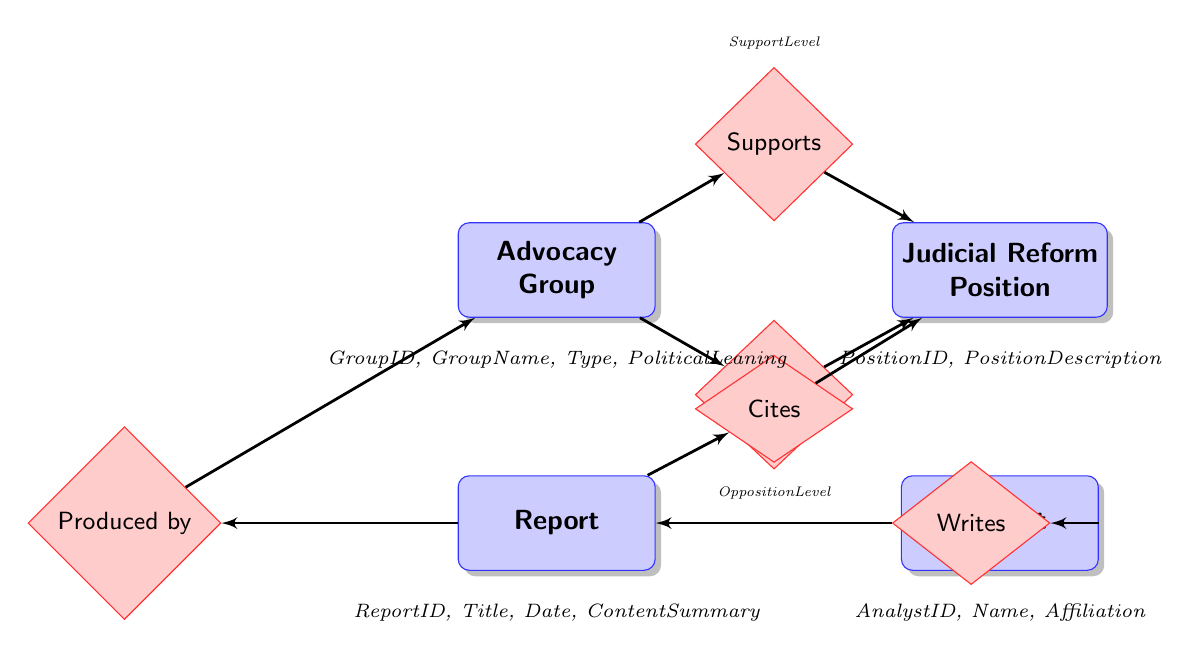What are the entities represented in the diagram? The entities in the diagram are Advocacy Group, Judicial Reform Position, Report, and Analyst. These are depicted as rectangles labeled with their names in the diagram.
Answer: Advocacy Group, Judicial Reform Position, Report, Analyst How many relationships are depicted between Advocacy Group and Judicial Reform Position? There are two relationships depicted between Advocacy Group and Judicial Reform Position: Supports and Opposes. Each of these relationships connects the two entities, indicating differing stances on judicial reform positions.
Answer: Two What attribute is associated with the Supports relationship? The attribute associated with the Supports relationship is SupportLevel. This attribute indicates how strongly an Advocacy Group supports a particular Judicial Reform Position.
Answer: SupportLevel Which entity produces the Report? The entity that produces the Report is Advocacy Group, as indicated by the relationship labeled "Produced by" connecting the Report entity to the Advocacy Group entity.
Answer: Advocacy Group Which entity writes the Report? The entity that writes the Report is Analyst. The relationship labeled "Writes" connects the Analyst entity to the Report entity, indicating that analysts are responsible for writing reports.
Answer: Analyst What does the Cites relationship connect? The Cites relationship connects the Report entity to the Judicial Reform Position entity. This implies that the Report includes references or mentions of specific Judicial Reform Positions.
Answer: Report to Judicial Reform Position How is the Advocacy Group related to the Judicial Reform Position? The Advocacy Group is related to the Judicial Reform Position through two distinct relationships: Supports and Opposes, highlighting the dual nature of advocacy around judicial reforms where groups can either support or oppose a position.
Answer: Supports and Opposes What kind of information can be found in the Report attributes? The Report attributes include ReportID, Title, Date, and ContentSummary, which provide respective identification, the name of the report, its publication date, and a summary of its contents.
Answer: ReportID, Title, Date, ContentSummary 